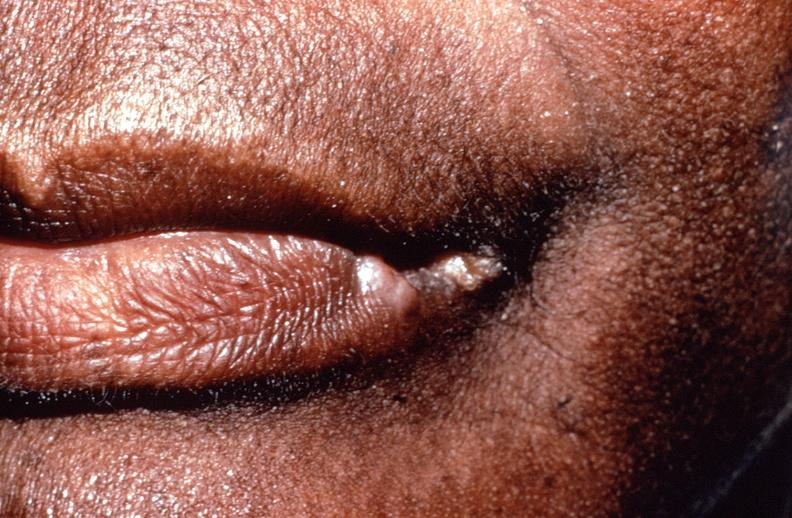does antitrypsin show squamous cell carcinoma, lip remote, healed?
Answer the question using a single word or phrase. No 